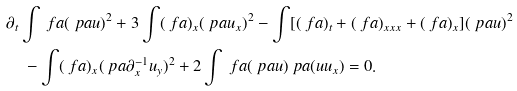<formula> <loc_0><loc_0><loc_500><loc_500>& \partial _ { t } \int \ f a ( \ p a u ) ^ { 2 } + 3 \int ( \ f a ) _ { x } ( \ p a u _ { x } ) ^ { 2 } - \int [ ( \ f a ) _ { t } + ( \ f a ) _ { x x x } + ( \ f a ) _ { x } ] ( \ p a u ) ^ { 2 } \\ & \quad - \int ( \ f a ) _ { x } ( \ p a \partial _ { x } ^ { - 1 } u _ { y } ) ^ { 2 } + 2 \int \ f a ( \ p a u ) \ p a ( u u _ { x } ) = 0 .</formula> 